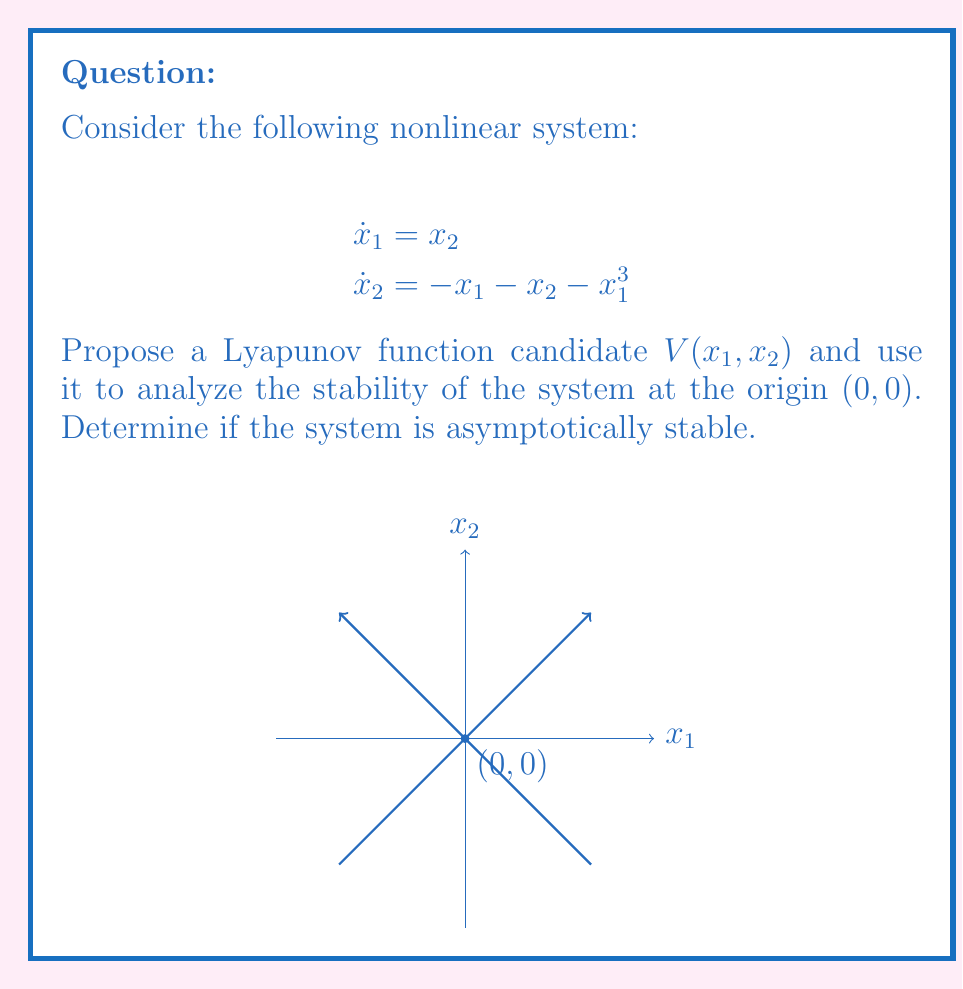Help me with this question. Let's approach this step-by-step:

1) First, we need to propose a Lyapunov function candidate. A common choice for second-order systems is a quadratic form:

   $$V(x_1, x_2) = \frac{1}{2}(x_1^2 + x_2^2)$$

2) To analyze stability using Lyapunov's direct method, we need to check three conditions:
   a) $V(0, 0) = 0$
   b) $V(x_1, x_2) > 0$ for all $(x_1, x_2) \neq (0, 0)$
   c) $\dot{V}(x_1, x_2) < 0$ for all $(x_1, x_2) \neq (0, 0)$

3) Let's check these conditions:
   a) $V(0, 0) = \frac{1}{2}(0^2 + 0^2) = 0$ (Satisfied)
   b) $V(x_1, x_2) = \frac{1}{2}(x_1^2 + x_2^2) > 0$ for all $(x_1, x_2) \neq (0, 0)$ (Satisfied)

4) Now, let's calculate $\dot{V}(x_1, x_2)$:

   $$\dot{V} = \frac{\partial V}{\partial x_1}\dot{x}_1 + \frac{\partial V}{\partial x_2}\dot{x}_2$$
   $$\dot{V} = x_1\dot{x}_1 + x_2\dot{x}_2$$
   $$\dot{V} = x_1x_2 + x_2(-x_1 - x_2 - x_1^3)$$
   $$\dot{V} = x_1x_2 - x_1x_2 - x_2^2 - x_1^3x_2$$
   $$\dot{V} = -x_2^2 - x_1^3x_2$$

5) We need to determine if $\dot{V} < 0$ for all $(x_1, x_2) \neq (0, 0)$:
   
   $-x_2^2$ is always non-positive.
   $-x_1^3x_2$ can be positive or negative depending on the values of $x_1$ and $x_2$.

   Therefore, we cannot guarantee that $\dot{V} < 0$ for all $(x_1, x_2) \neq (0, 0)$.

6) However, we can conclude that $\dot{V} \leq 0$ for all $(x_1, x_2)$, which implies stability (but not asymptotic stability) according to Lyapunov's stability theorem.

7) To prove asymptotic stability, we would need to use LaSalle's Invariance Principle or find a stricter Lyapunov function.
Answer: The system is stable but not necessarily asymptotically stable at the origin. 